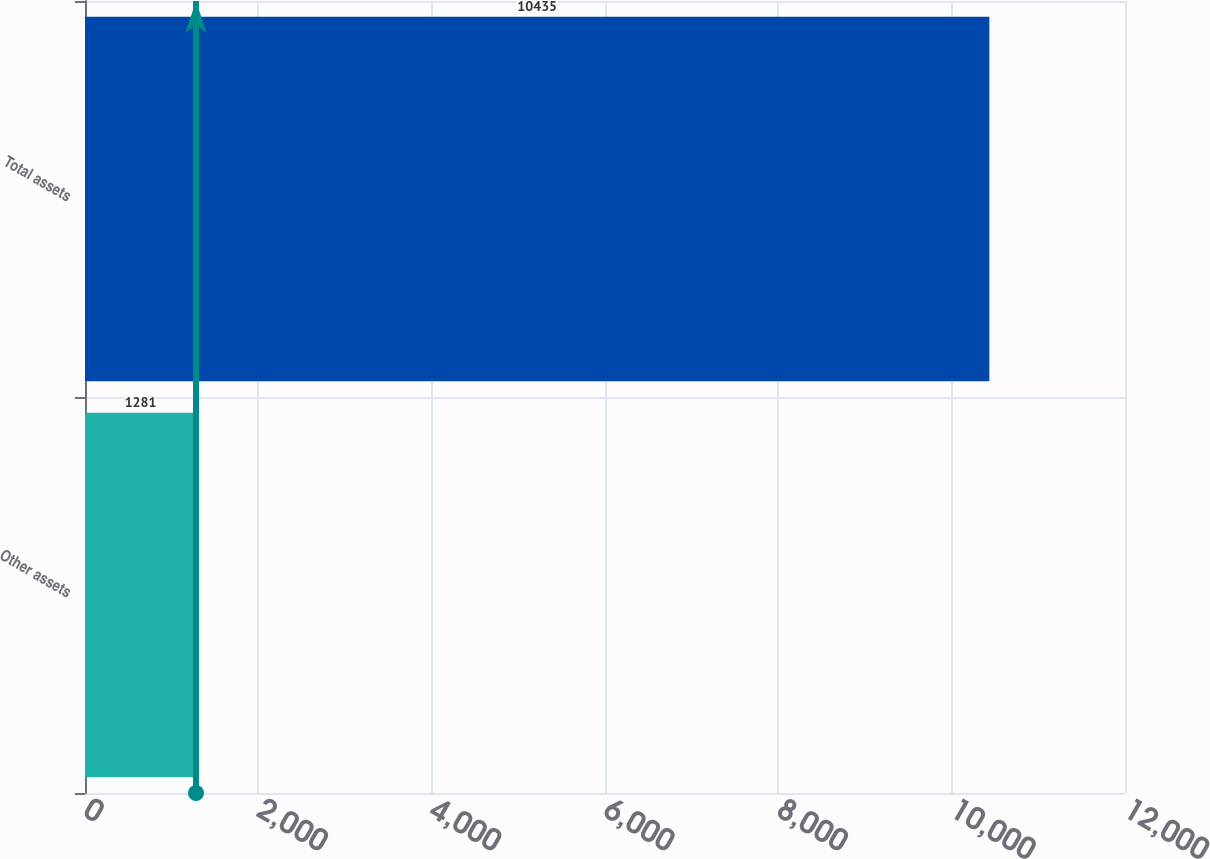Convert chart to OTSL. <chart><loc_0><loc_0><loc_500><loc_500><bar_chart><fcel>Other assets<fcel>Total assets<nl><fcel>1281<fcel>10435<nl></chart> 